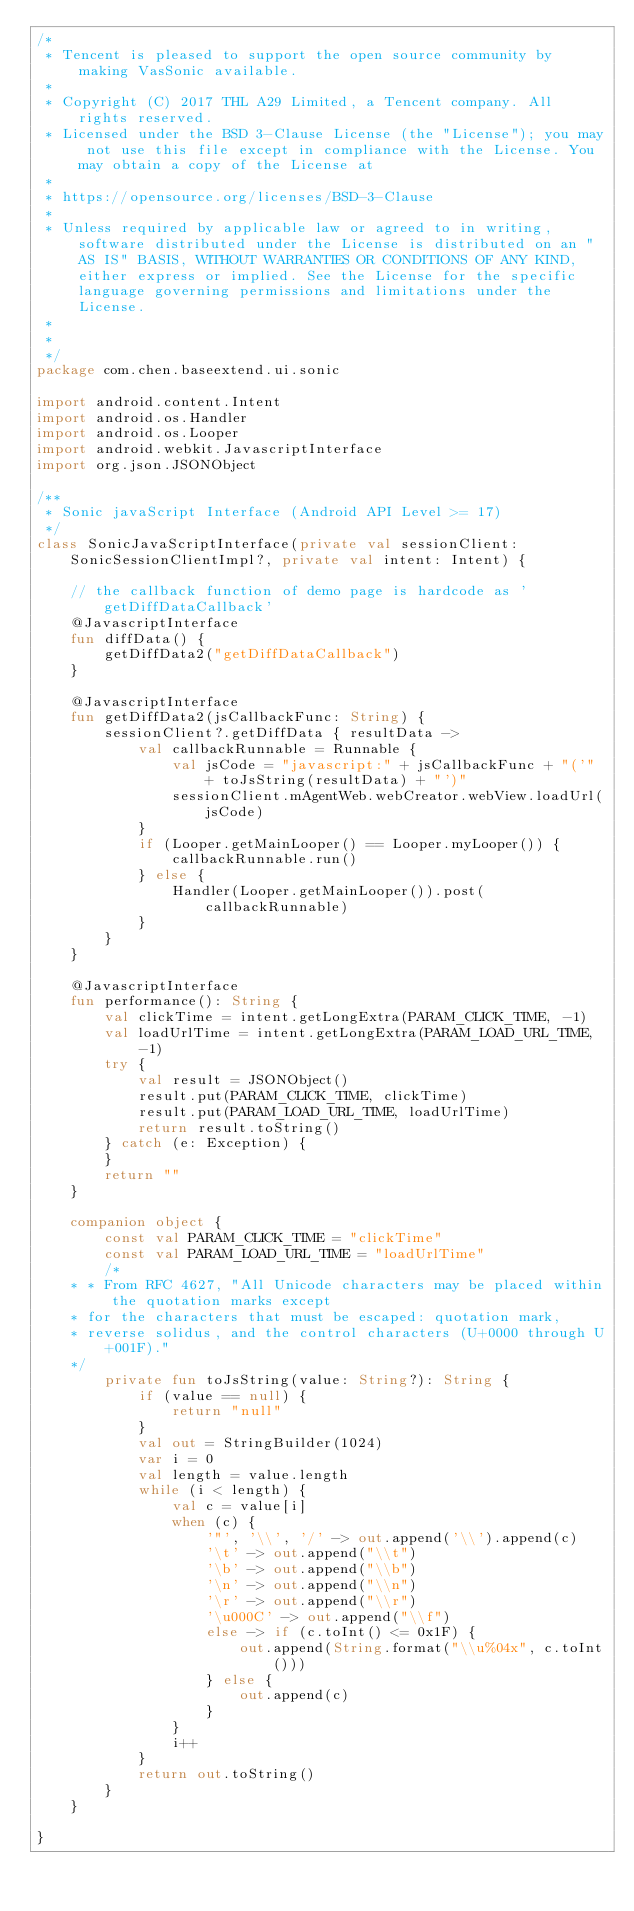Convert code to text. <code><loc_0><loc_0><loc_500><loc_500><_Kotlin_>/*
 * Tencent is pleased to support the open source community by making VasSonic available.
 *
 * Copyright (C) 2017 THL A29 Limited, a Tencent company. All rights reserved.
 * Licensed under the BSD 3-Clause License (the "License"); you may not use this file except in compliance with the License. You may obtain a copy of the License at
 *
 * https://opensource.org/licenses/BSD-3-Clause
 *
 * Unless required by applicable law or agreed to in writing, software distributed under the License is distributed on an "AS IS" BASIS, WITHOUT WARRANTIES OR CONDITIONS OF ANY KIND, either express or implied. See the License for the specific language governing permissions and limitations under the License.
 *
 *
 */
package com.chen.baseextend.ui.sonic

import android.content.Intent
import android.os.Handler
import android.os.Looper
import android.webkit.JavascriptInterface
import org.json.JSONObject

/**
 * Sonic javaScript Interface (Android API Level >= 17)
 */
class SonicJavaScriptInterface(private val sessionClient: SonicSessionClientImpl?, private val intent: Intent) {

    // the callback function of demo page is hardcode as 'getDiffDataCallback'
    @JavascriptInterface
    fun diffData() {
        getDiffData2("getDiffDataCallback")
    }

    @JavascriptInterface
    fun getDiffData2(jsCallbackFunc: String) {
        sessionClient?.getDiffData { resultData ->
            val callbackRunnable = Runnable {
                val jsCode = "javascript:" + jsCallbackFunc + "('" + toJsString(resultData) + "')"
                sessionClient.mAgentWeb.webCreator.webView.loadUrl(jsCode)
            }
            if (Looper.getMainLooper() == Looper.myLooper()) {
                callbackRunnable.run()
            } else {
                Handler(Looper.getMainLooper()).post(callbackRunnable)
            }
        }
    }

    @JavascriptInterface
    fun performance(): String {
        val clickTime = intent.getLongExtra(PARAM_CLICK_TIME, -1)
        val loadUrlTime = intent.getLongExtra(PARAM_LOAD_URL_TIME, -1)
        try {
            val result = JSONObject()
            result.put(PARAM_CLICK_TIME, clickTime)
            result.put(PARAM_LOAD_URL_TIME, loadUrlTime)
            return result.toString()
        } catch (e: Exception) {
        }
        return ""
    }

    companion object {
        const val PARAM_CLICK_TIME = "clickTime"
        const val PARAM_LOAD_URL_TIME = "loadUrlTime"
        /*
    * * From RFC 4627, "All Unicode characters may be placed within the quotation marks except
    * for the characters that must be escaped: quotation mark,
    * reverse solidus, and the control characters (U+0000 through U+001F)."
    */
        private fun toJsString(value: String?): String {
            if (value == null) {
                return "null"
            }
            val out = StringBuilder(1024)
            var i = 0
            val length = value.length
            while (i < length) {
                val c = value[i]
                when (c) {
                    '"', '\\', '/' -> out.append('\\').append(c)
                    '\t' -> out.append("\\t")
                    '\b' -> out.append("\\b")
                    '\n' -> out.append("\\n")
                    '\r' -> out.append("\\r")
                    '\u000C' -> out.append("\\f")
                    else -> if (c.toInt() <= 0x1F) {
                        out.append(String.format("\\u%04x", c.toInt()))
                    } else {
                        out.append(c)
                    }
                }
                i++
            }
            return out.toString()
        }
    }

}</code> 